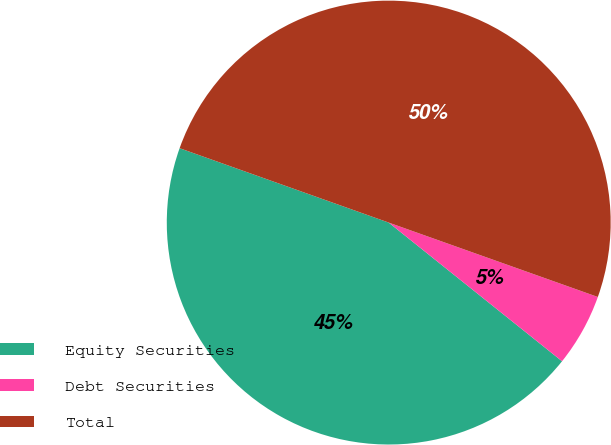Convert chart to OTSL. <chart><loc_0><loc_0><loc_500><loc_500><pie_chart><fcel>Equity Securities<fcel>Debt Securities<fcel>Total<nl><fcel>44.7%<fcel>5.3%<fcel>50.0%<nl></chart> 